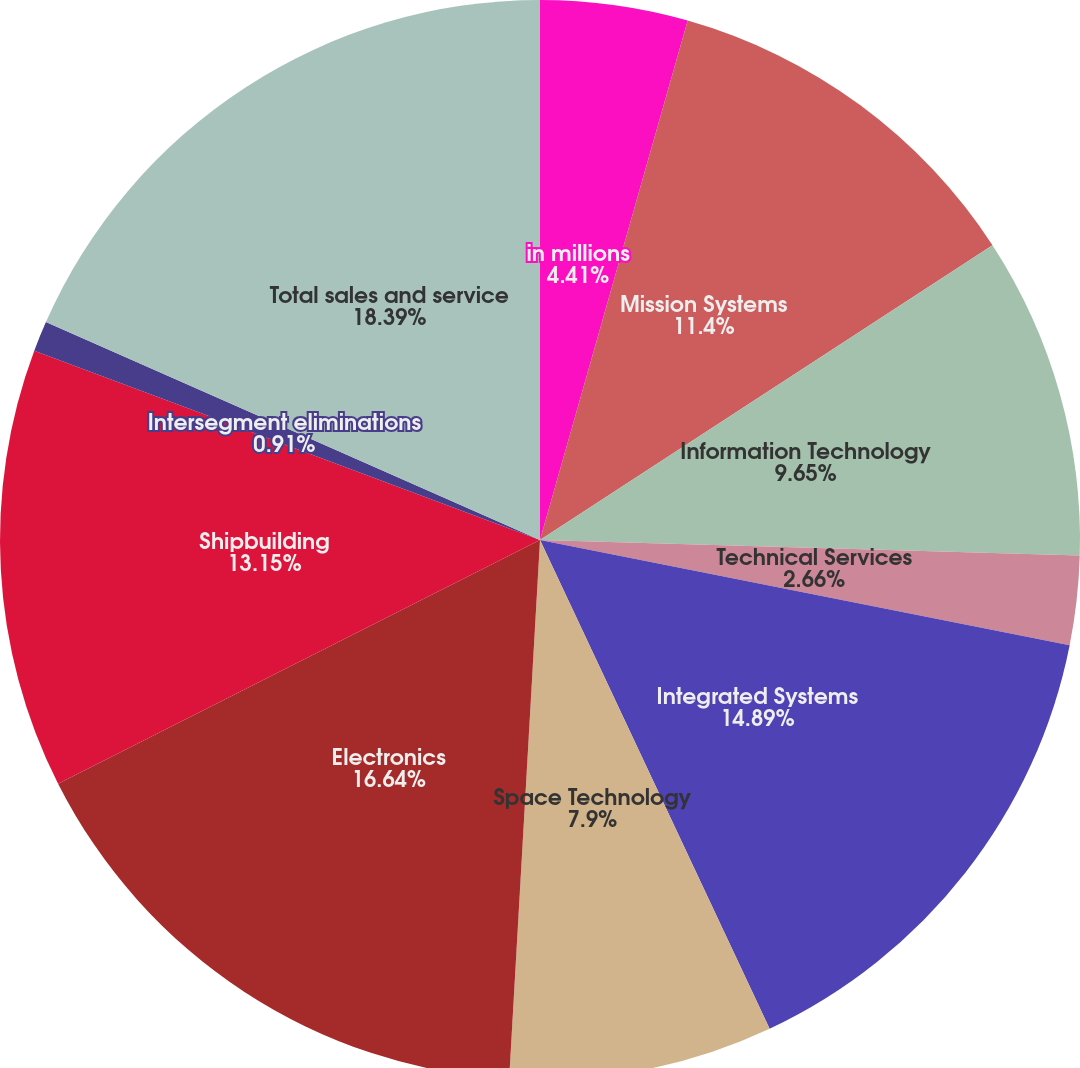<chart> <loc_0><loc_0><loc_500><loc_500><pie_chart><fcel>in millions<fcel>Mission Systems<fcel>Information Technology<fcel>Technical Services<fcel>Integrated Systems<fcel>Space Technology<fcel>Electronics<fcel>Shipbuilding<fcel>Intersegment eliminations<fcel>Total sales and service<nl><fcel>4.41%<fcel>11.4%<fcel>9.65%<fcel>2.66%<fcel>14.89%<fcel>7.9%<fcel>16.64%<fcel>13.15%<fcel>0.91%<fcel>18.39%<nl></chart> 